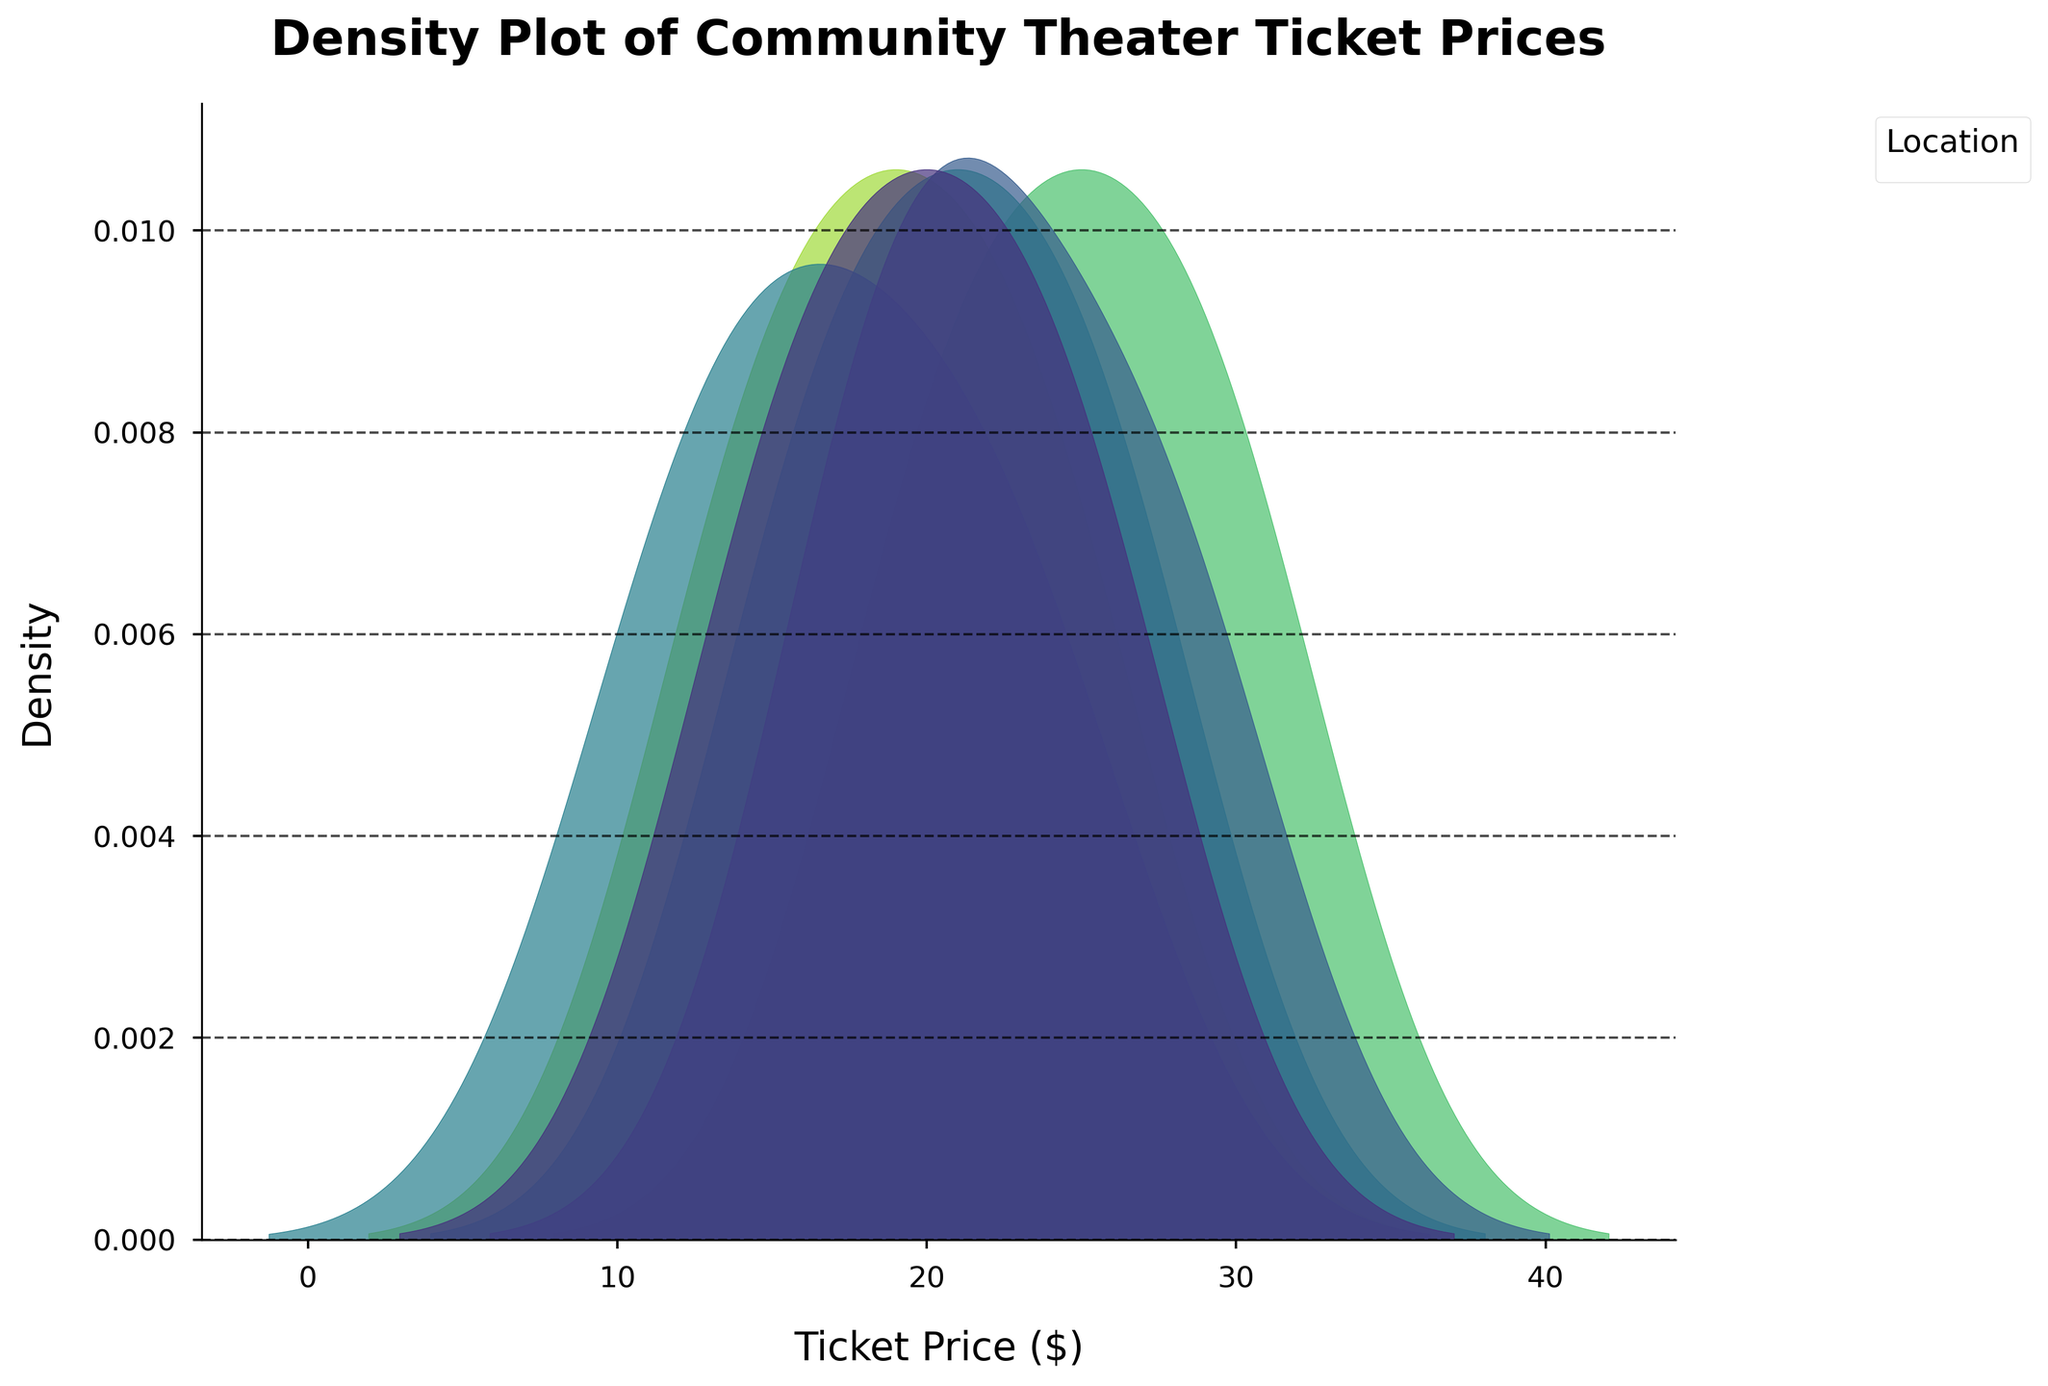What is the title of the plot? The title is displayed at the top of the plot, stylized with a bold font, making it quite easy to locate and read.
Answer: Density Plot of Community Theater Ticket Prices What are the labels of the x-axis and y-axis? Labels are typically positioned along their respective axes. The x-axis label explains the horizontal metric, and the y-axis label explains the vertical metric.
Answer: Ticket Price ($), Density Which location has the highest peak in ticket price density? The highest peak in density indicates the most common ticket price range for that location. By looking at the tallest area under the curve, we can identify the location.
Answer: Palm Springs CA What is the range of ticket prices shown on the x-axis? Observing the start and end points of the x-axis will give the range. It spans from the minimum to the maximum ticket prices displayed.
Answer: $12 to $30 How do the ticket price densities for Riverside CA and San Bernardino CA compare? By observing the density curves for both Riverside CA and San Bernardino CA, we can compare the spread and peaks of the ticket prices in these locations.
Answer: Riverside CA has a wider spread between $15-$25, while San Bernardino CA has a peak around $18-$28 Which location has the broadest range of ticket prices according to the plot? The broadest range is indicated by the location whose density plot stretches the most along the x-axis.
Answer: Palm Springs CA Are there any locations with overlapping ticket price densities? Observing where the density curves from different locations intersect will indicate overlapping.
Answer: Yes, some overlap can be seen, especially between Riverside CA and San Bernardino CA Which location has the narrowest range of ticket prices? The narrowest range can be identified by the density plot that is most concentrated, indicating less variation in ticket prices.
Answer: Redlands CA How does the ticket price density for Ontario CA compare to that of Temecula CA? Both locations’ density plots should be observed to see differences in their spread and common ticket price ranges.
Answer: Ontario CA has a peak density around $21, while Temecula CA peaks around $19 What is the most densely packed ticket price for Redlands CA? By finding the peak density value for Redlands CA, we can observe where ticket prices are most clustered.
Answer: Around $17 